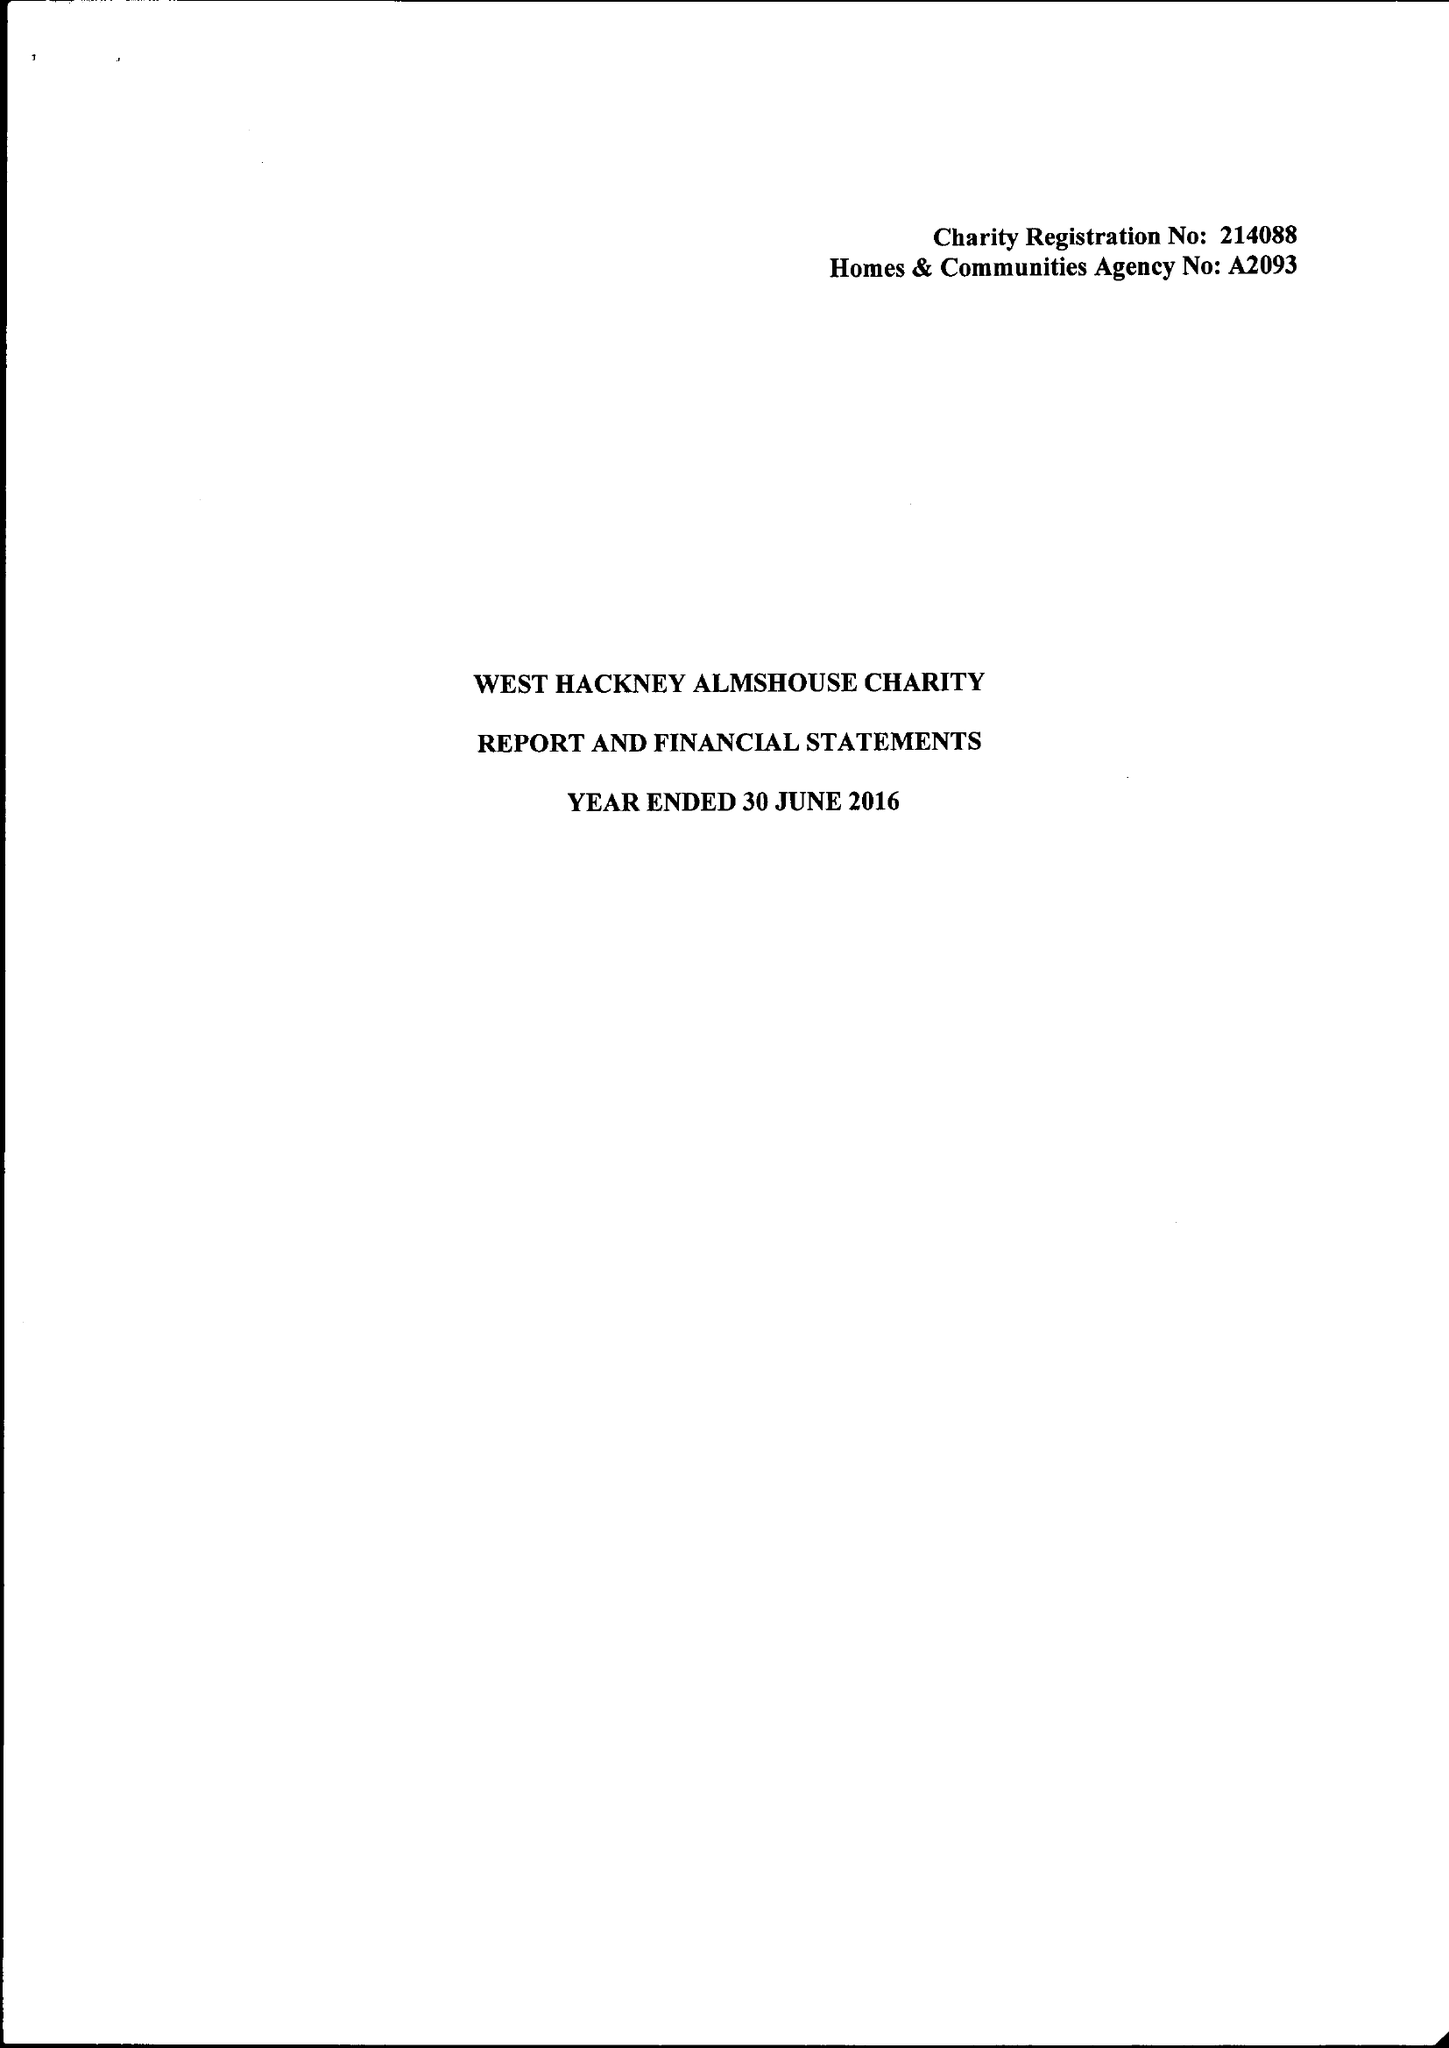What is the value for the spending_annually_in_british_pounds?
Answer the question using a single word or phrase. 58514.00 